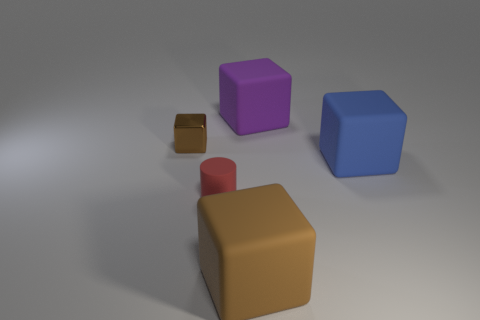Is the number of rubber things that are in front of the tiny brown shiny block less than the number of small matte cylinders right of the big blue thing?
Your response must be concise. No. There is a tiny rubber cylinder; are there any purple cubes on the left side of it?
Ensure brevity in your answer.  No. Is there a brown matte object that is in front of the big rubber block that is in front of the matte cylinder that is on the left side of the big brown matte cube?
Offer a very short reply. No. Do the rubber thing in front of the red thing and the small metal object have the same shape?
Make the answer very short. Yes. There is a cylinder that is the same material as the large brown thing; what is its color?
Your response must be concise. Red. How many other tiny red objects have the same material as the small red thing?
Your answer should be compact. 0. What color is the rubber object on the left side of the block in front of the small object to the right of the small brown shiny thing?
Your answer should be compact. Red. Do the red object and the brown metal thing have the same size?
Make the answer very short. Yes. Is there anything else that is the same shape as the big purple matte thing?
Keep it short and to the point. Yes. How many things are either brown blocks to the right of the red rubber object or blocks?
Provide a short and direct response. 4. 